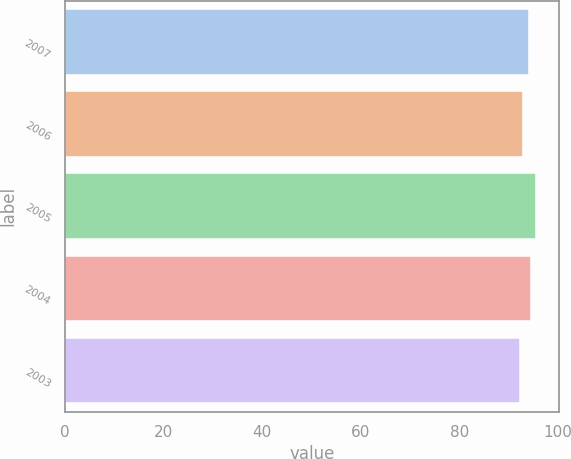Convert chart to OTSL. <chart><loc_0><loc_0><loc_500><loc_500><bar_chart><fcel>2007<fcel>2006<fcel>2005<fcel>2004<fcel>2003<nl><fcel>94.1<fcel>92.9<fcel>95.5<fcel>94.5<fcel>92.3<nl></chart> 